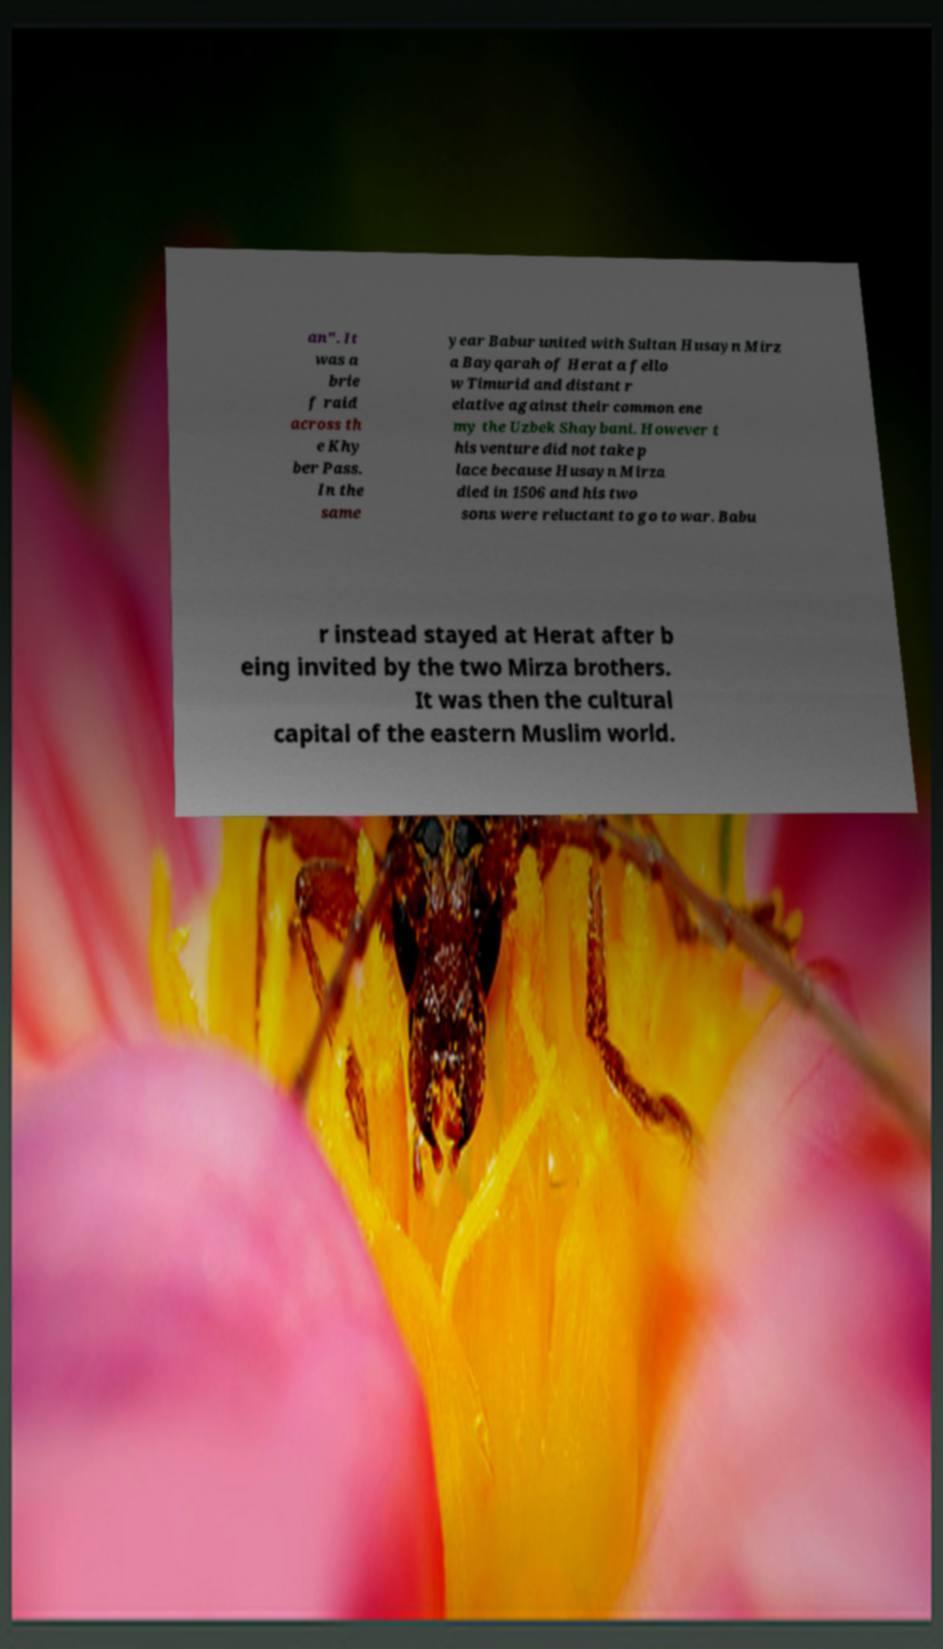There's text embedded in this image that I need extracted. Can you transcribe it verbatim? an". It was a brie f raid across th e Khy ber Pass. In the same year Babur united with Sultan Husayn Mirz a Bayqarah of Herat a fello w Timurid and distant r elative against their common ene my the Uzbek Shaybani. However t his venture did not take p lace because Husayn Mirza died in 1506 and his two sons were reluctant to go to war. Babu r instead stayed at Herat after b eing invited by the two Mirza brothers. It was then the cultural capital of the eastern Muslim world. 